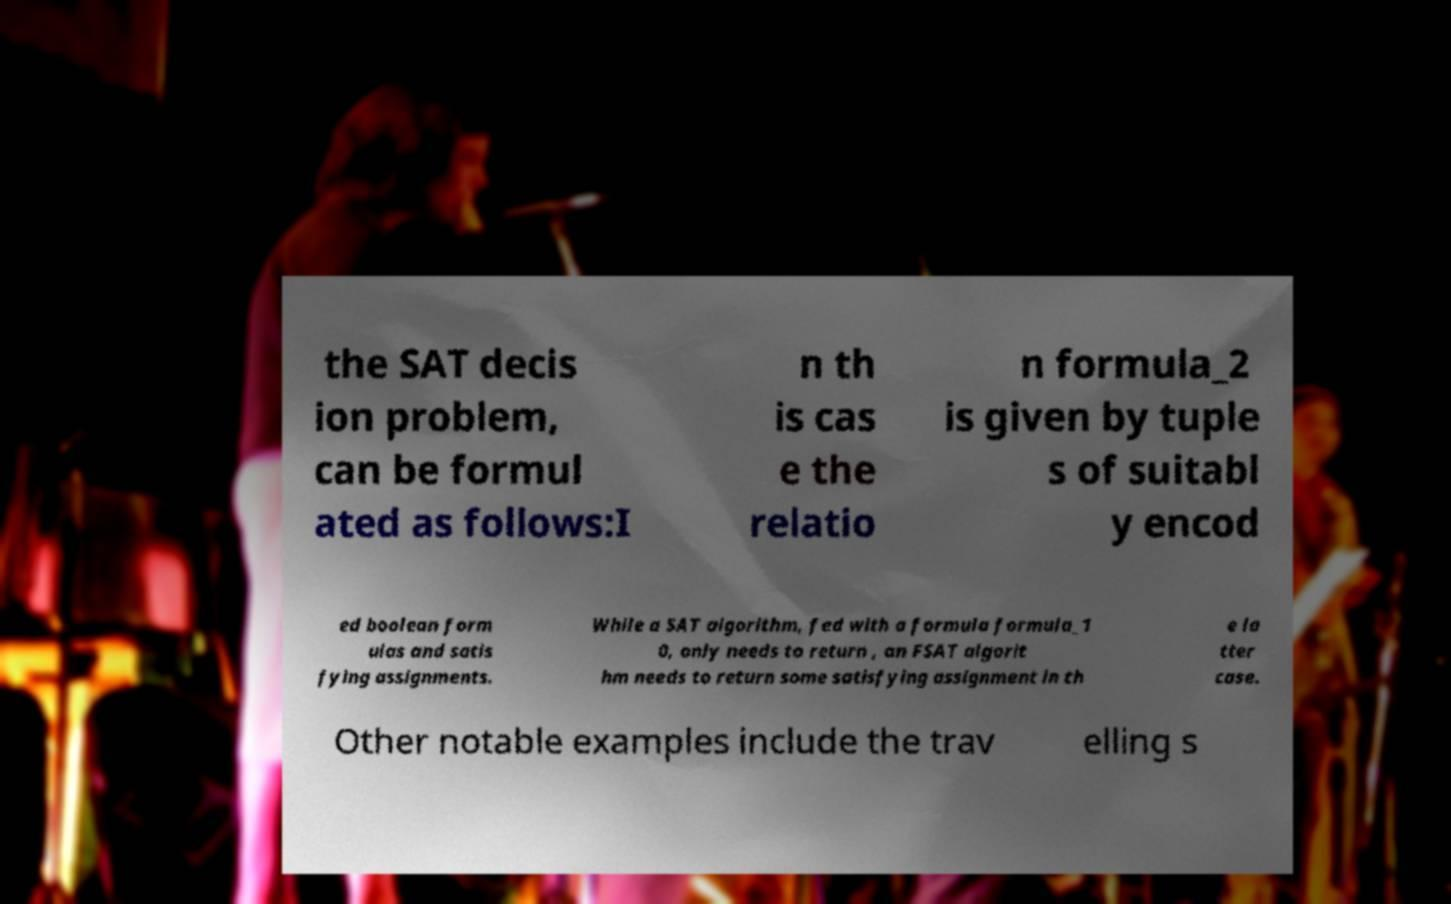Could you assist in decoding the text presented in this image and type it out clearly? the SAT decis ion problem, can be formul ated as follows:I n th is cas e the relatio n formula_2 is given by tuple s of suitabl y encod ed boolean form ulas and satis fying assignments. While a SAT algorithm, fed with a formula formula_1 0, only needs to return , an FSAT algorit hm needs to return some satisfying assignment in th e la tter case. Other notable examples include the trav elling s 